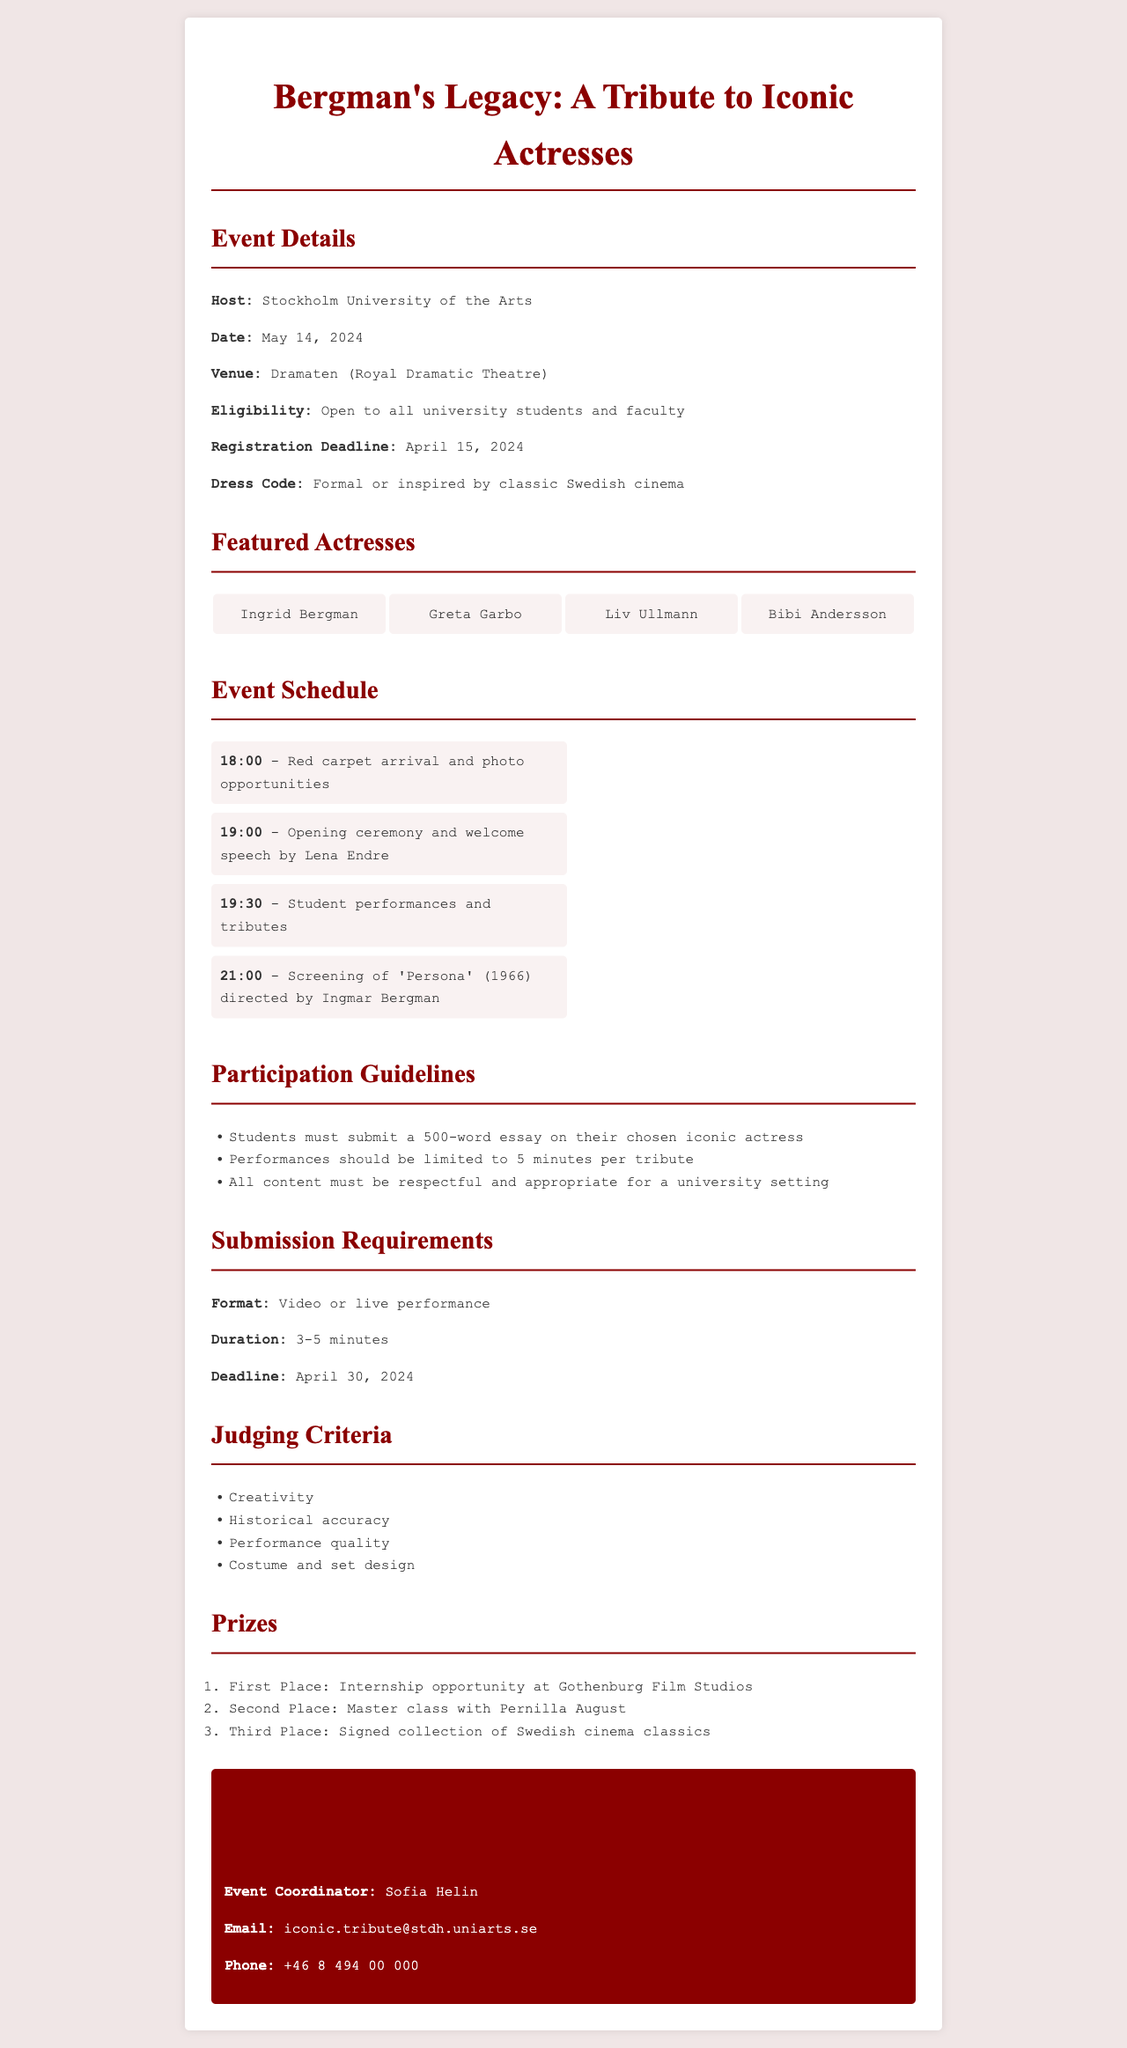What is the host of the event? The policy document specifies that the host of the event is Stockholm University of the Arts.
Answer: Stockholm University of the Arts What is the registration deadline? The document states that participants must register by a specific date, which is April 15, 2024.
Answer: April 15, 2024 Who will give the welcome speech? According to the event schedule, the welcome speech will be given by Lena Endre.
Answer: Lena Endre What is the maximum duration of student performances? The guidelines specify a limit for the performance duration, which is 5 minutes per tribute.
Answer: 5 minutes What criteria will be used for judging? The document lists several criteria for judging the performances, one of which is creativity.
Answer: Creativity Which actress is featured as the first place prize? The document states that the first place prize offers an internship opportunity at Gothenburg Film Studios.
Answer: Internship opportunity at Gothenburg Film Studios What is the event date? The date of the event is clearly mentioned in the document as May 14, 2024.
Answer: May 14, 2024 How many featured actresses are listed? The document outlines four specific iconic actresses featured in the event.
Answer: Four What is the contact email for the event coordinator? The policy document provides a specific email for inquiries, which is iconic.tribute@stdh.uniarts.se.
Answer: iconic.tribute@stdh.uniarts.se 